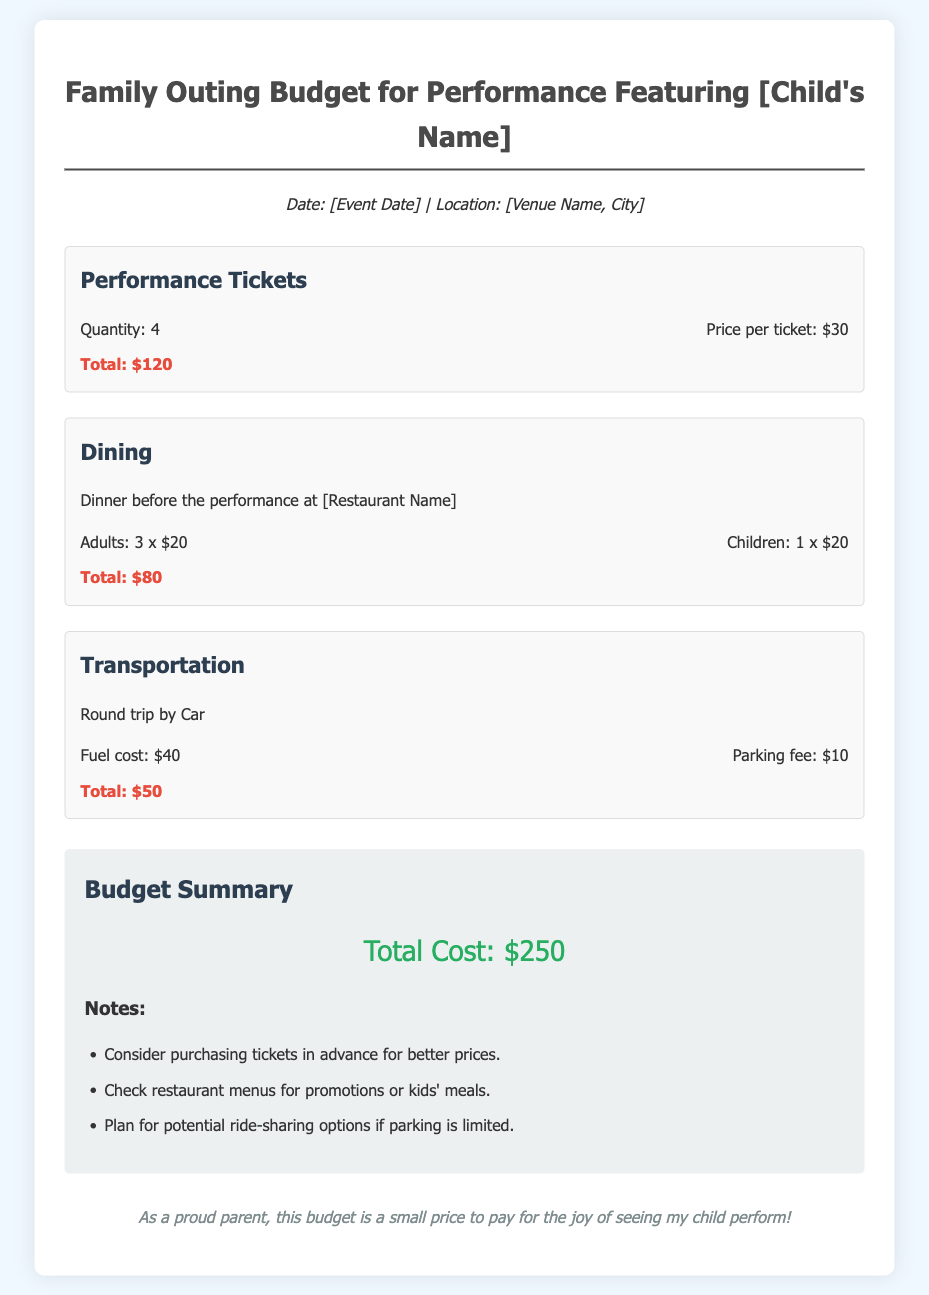What is the total cost for performance tickets? The total cost for performance tickets is calculated from the quantity of tickets multiplied by the price per ticket, which is 4 tickets at $30 each.
Answer: $120 What date is the performance scheduled for? The document states the date of the event but it is represented as a placeholder.
Answer: [Event Date] How many adults are dining before the performance? The document specifies the number of adults dining, which is included in the dining section.
Answer: 3 What is the parking fee for the outing? The parking fee is mentioned in the transportation section of the document.
Answer: $10 What is the total cost for dining? The total cost for dining is calculated based on the number of adults and children dining, which is 3 adults and 1 child at $20 each.
Answer: $80 What is the venue name for the performance? The venue name is indicated as a placeholder in the document.
Answer: [Venue Name, City] How much is allocated for fuel costs? The fuel cost is specified as a separate line item under transportation expenses.
Answer: $40 What is the total cost of the outing? The total cost of the outing is derived by adding up the costs from tickets, dining, and transportation categories.
Answer: $250 What restaurant is suggested for dining? The document mentions the restaurant name as a placeholder for dining before the performance.
Answer: [Restaurant Name] 